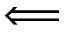Convert formula to latex. <formula><loc_0><loc_0><loc_500><loc_500>\Longleftarrow</formula> 